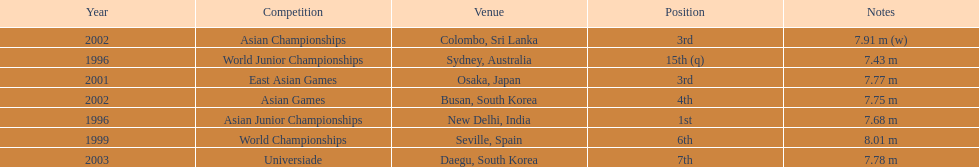Which year was his best jump? 1999. 